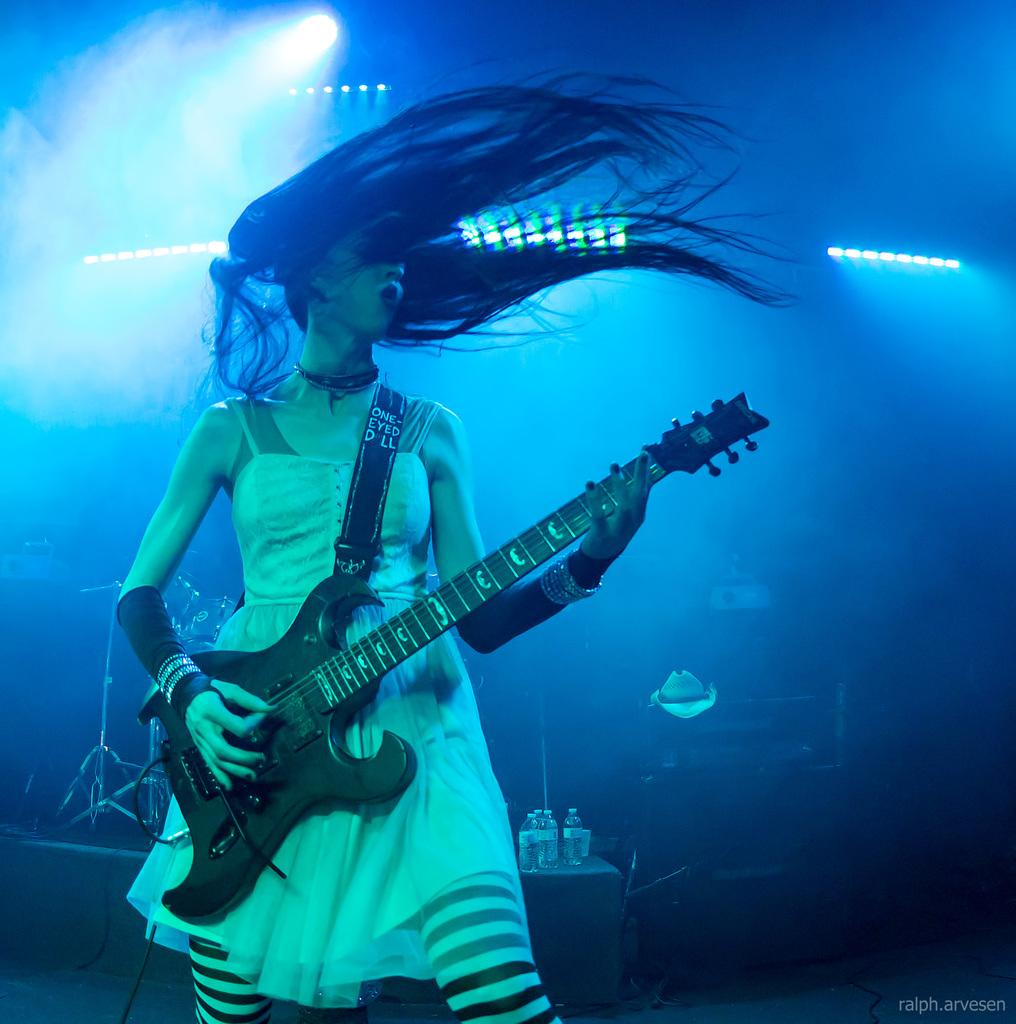Who is the main subject in the image? There is a woman in the image. What is the woman holding in the image? The woman is holding a guitar. What is the woman doing with the guitar? The woman is playing the guitar. What can be seen in the background of the image? There are colorful lights visible in the background. What type of crime is being committed in the image? There is no crime being committed in the image; it features a woman playing a guitar. What kind of nut is used to hold the guitar strings in place in the image? There is no nut visible in the image, as it is a part of the guitar's internal mechanism and not visible when playing. 